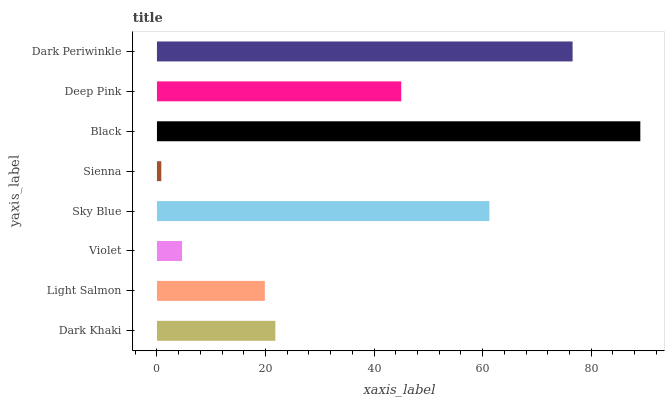Is Sienna the minimum?
Answer yes or no. Yes. Is Black the maximum?
Answer yes or no. Yes. Is Light Salmon the minimum?
Answer yes or no. No. Is Light Salmon the maximum?
Answer yes or no. No. Is Dark Khaki greater than Light Salmon?
Answer yes or no. Yes. Is Light Salmon less than Dark Khaki?
Answer yes or no. Yes. Is Light Salmon greater than Dark Khaki?
Answer yes or no. No. Is Dark Khaki less than Light Salmon?
Answer yes or no. No. Is Deep Pink the high median?
Answer yes or no. Yes. Is Dark Khaki the low median?
Answer yes or no. Yes. Is Dark Khaki the high median?
Answer yes or no. No. Is Violet the low median?
Answer yes or no. No. 